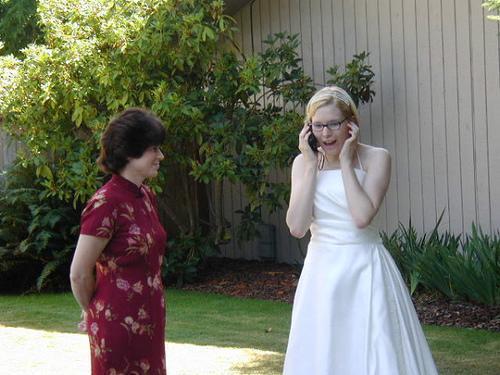How many people are there?
Give a very brief answer. 2. How many cell phones are visible?
Give a very brief answer. 1. 